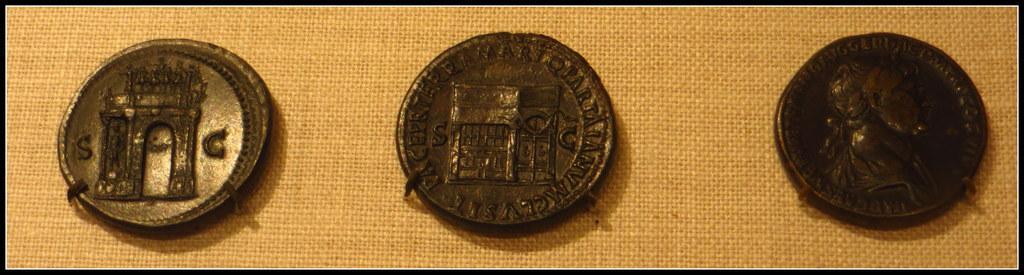Can you describe this image briefly? In this image I can see three coins which are black and brown in color. I can see the brown colored background. 